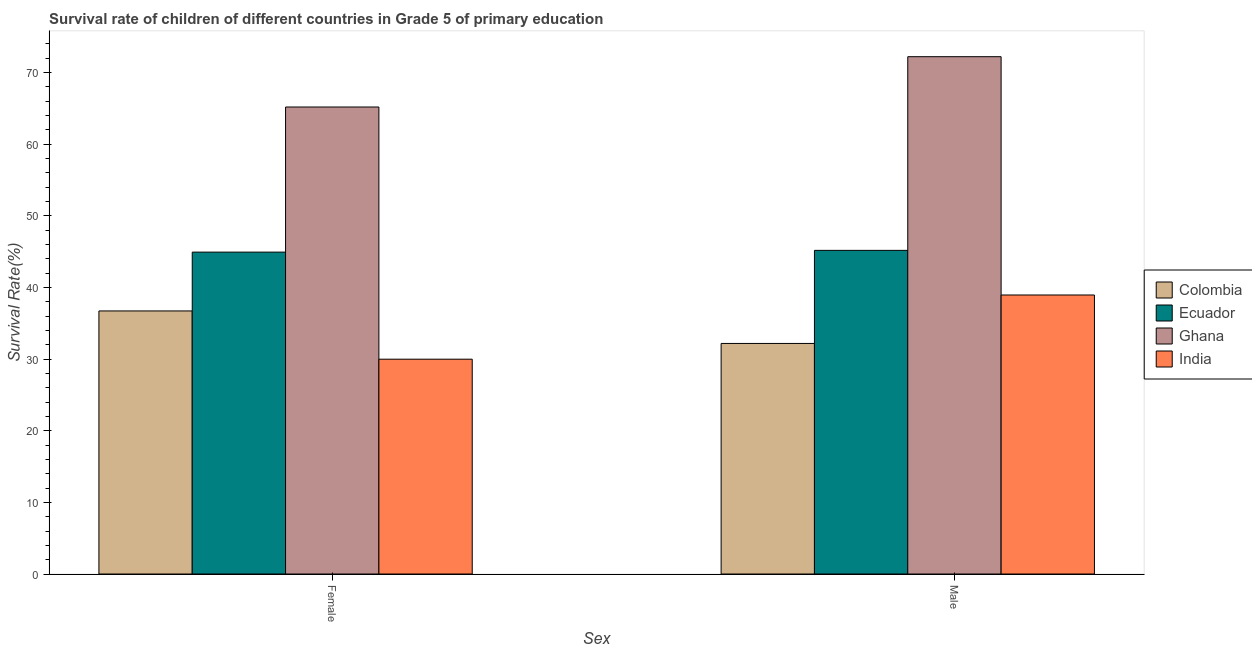How many different coloured bars are there?
Keep it short and to the point. 4. Are the number of bars per tick equal to the number of legend labels?
Your response must be concise. Yes. How many bars are there on the 2nd tick from the left?
Offer a very short reply. 4. How many bars are there on the 1st tick from the right?
Provide a short and direct response. 4. What is the label of the 1st group of bars from the left?
Ensure brevity in your answer.  Female. What is the survival rate of female students in primary education in Ghana?
Your answer should be very brief. 65.17. Across all countries, what is the maximum survival rate of male students in primary education?
Your answer should be very brief. 72.19. Across all countries, what is the minimum survival rate of female students in primary education?
Make the answer very short. 29.97. In which country was the survival rate of male students in primary education minimum?
Your answer should be very brief. Colombia. What is the total survival rate of female students in primary education in the graph?
Provide a short and direct response. 176.77. What is the difference between the survival rate of female students in primary education in Ecuador and that in Colombia?
Your answer should be compact. 8.21. What is the difference between the survival rate of male students in primary education in Ghana and the survival rate of female students in primary education in Colombia?
Make the answer very short. 35.48. What is the average survival rate of female students in primary education per country?
Your answer should be compact. 44.19. What is the difference between the survival rate of female students in primary education and survival rate of male students in primary education in Ecuador?
Make the answer very short. -0.24. In how many countries, is the survival rate of female students in primary education greater than 2 %?
Give a very brief answer. 4. What is the ratio of the survival rate of female students in primary education in Colombia to that in Ecuador?
Provide a succinct answer. 0.82. In how many countries, is the survival rate of male students in primary education greater than the average survival rate of male students in primary education taken over all countries?
Your answer should be very brief. 1. How many bars are there?
Provide a succinct answer. 8. Are all the bars in the graph horizontal?
Offer a terse response. No. How many countries are there in the graph?
Your answer should be compact. 4. Are the values on the major ticks of Y-axis written in scientific E-notation?
Offer a very short reply. No. Does the graph contain any zero values?
Provide a succinct answer. No. Where does the legend appear in the graph?
Give a very brief answer. Center right. How are the legend labels stacked?
Your answer should be very brief. Vertical. What is the title of the graph?
Keep it short and to the point. Survival rate of children of different countries in Grade 5 of primary education. Does "Latvia" appear as one of the legend labels in the graph?
Make the answer very short. No. What is the label or title of the X-axis?
Keep it short and to the point. Sex. What is the label or title of the Y-axis?
Your answer should be very brief. Survival Rate(%). What is the Survival Rate(%) in Colombia in Female?
Provide a succinct answer. 36.71. What is the Survival Rate(%) in Ecuador in Female?
Give a very brief answer. 44.92. What is the Survival Rate(%) in Ghana in Female?
Ensure brevity in your answer.  65.17. What is the Survival Rate(%) of India in Female?
Ensure brevity in your answer.  29.97. What is the Survival Rate(%) of Colombia in Male?
Your answer should be compact. 32.17. What is the Survival Rate(%) of Ecuador in Male?
Give a very brief answer. 45.16. What is the Survival Rate(%) in Ghana in Male?
Give a very brief answer. 72.19. What is the Survival Rate(%) of India in Male?
Ensure brevity in your answer.  38.93. Across all Sex, what is the maximum Survival Rate(%) in Colombia?
Provide a short and direct response. 36.71. Across all Sex, what is the maximum Survival Rate(%) of Ecuador?
Your answer should be very brief. 45.16. Across all Sex, what is the maximum Survival Rate(%) of Ghana?
Give a very brief answer. 72.19. Across all Sex, what is the maximum Survival Rate(%) in India?
Your answer should be very brief. 38.93. Across all Sex, what is the minimum Survival Rate(%) in Colombia?
Keep it short and to the point. 32.17. Across all Sex, what is the minimum Survival Rate(%) of Ecuador?
Provide a succinct answer. 44.92. Across all Sex, what is the minimum Survival Rate(%) of Ghana?
Your answer should be very brief. 65.17. Across all Sex, what is the minimum Survival Rate(%) in India?
Your answer should be compact. 29.97. What is the total Survival Rate(%) of Colombia in the graph?
Your answer should be very brief. 68.88. What is the total Survival Rate(%) in Ecuador in the graph?
Provide a succinct answer. 90.08. What is the total Survival Rate(%) of Ghana in the graph?
Keep it short and to the point. 137.35. What is the total Survival Rate(%) of India in the graph?
Keep it short and to the point. 68.91. What is the difference between the Survival Rate(%) of Colombia in Female and that in Male?
Offer a terse response. 4.54. What is the difference between the Survival Rate(%) of Ecuador in Female and that in Male?
Your answer should be compact. -0.24. What is the difference between the Survival Rate(%) of Ghana in Female and that in Male?
Your answer should be compact. -7.02. What is the difference between the Survival Rate(%) of India in Female and that in Male?
Offer a very short reply. -8.96. What is the difference between the Survival Rate(%) of Colombia in Female and the Survival Rate(%) of Ecuador in Male?
Your response must be concise. -8.45. What is the difference between the Survival Rate(%) of Colombia in Female and the Survival Rate(%) of Ghana in Male?
Ensure brevity in your answer.  -35.48. What is the difference between the Survival Rate(%) in Colombia in Female and the Survival Rate(%) in India in Male?
Make the answer very short. -2.23. What is the difference between the Survival Rate(%) of Ecuador in Female and the Survival Rate(%) of Ghana in Male?
Keep it short and to the point. -27.27. What is the difference between the Survival Rate(%) in Ecuador in Female and the Survival Rate(%) in India in Male?
Provide a succinct answer. 5.98. What is the difference between the Survival Rate(%) of Ghana in Female and the Survival Rate(%) of India in Male?
Provide a succinct answer. 26.23. What is the average Survival Rate(%) of Colombia per Sex?
Provide a short and direct response. 34.44. What is the average Survival Rate(%) of Ecuador per Sex?
Your response must be concise. 45.04. What is the average Survival Rate(%) in Ghana per Sex?
Keep it short and to the point. 68.68. What is the average Survival Rate(%) in India per Sex?
Your answer should be very brief. 34.45. What is the difference between the Survival Rate(%) in Colombia and Survival Rate(%) in Ecuador in Female?
Make the answer very short. -8.21. What is the difference between the Survival Rate(%) in Colombia and Survival Rate(%) in Ghana in Female?
Your answer should be very brief. -28.46. What is the difference between the Survival Rate(%) in Colombia and Survival Rate(%) in India in Female?
Your response must be concise. 6.73. What is the difference between the Survival Rate(%) in Ecuador and Survival Rate(%) in Ghana in Female?
Offer a very short reply. -20.25. What is the difference between the Survival Rate(%) in Ecuador and Survival Rate(%) in India in Female?
Your answer should be compact. 14.94. What is the difference between the Survival Rate(%) of Ghana and Survival Rate(%) of India in Female?
Make the answer very short. 35.19. What is the difference between the Survival Rate(%) in Colombia and Survival Rate(%) in Ecuador in Male?
Ensure brevity in your answer.  -12.99. What is the difference between the Survival Rate(%) of Colombia and Survival Rate(%) of Ghana in Male?
Keep it short and to the point. -40.02. What is the difference between the Survival Rate(%) of Colombia and Survival Rate(%) of India in Male?
Offer a very short reply. -6.76. What is the difference between the Survival Rate(%) in Ecuador and Survival Rate(%) in Ghana in Male?
Provide a short and direct response. -27.03. What is the difference between the Survival Rate(%) in Ecuador and Survival Rate(%) in India in Male?
Provide a succinct answer. 6.23. What is the difference between the Survival Rate(%) in Ghana and Survival Rate(%) in India in Male?
Ensure brevity in your answer.  33.25. What is the ratio of the Survival Rate(%) in Colombia in Female to that in Male?
Provide a short and direct response. 1.14. What is the ratio of the Survival Rate(%) in Ghana in Female to that in Male?
Ensure brevity in your answer.  0.9. What is the ratio of the Survival Rate(%) in India in Female to that in Male?
Your answer should be compact. 0.77. What is the difference between the highest and the second highest Survival Rate(%) in Colombia?
Your response must be concise. 4.54. What is the difference between the highest and the second highest Survival Rate(%) in Ecuador?
Give a very brief answer. 0.24. What is the difference between the highest and the second highest Survival Rate(%) in Ghana?
Ensure brevity in your answer.  7.02. What is the difference between the highest and the second highest Survival Rate(%) in India?
Your answer should be very brief. 8.96. What is the difference between the highest and the lowest Survival Rate(%) in Colombia?
Provide a succinct answer. 4.54. What is the difference between the highest and the lowest Survival Rate(%) of Ecuador?
Provide a short and direct response. 0.24. What is the difference between the highest and the lowest Survival Rate(%) in Ghana?
Offer a very short reply. 7.02. What is the difference between the highest and the lowest Survival Rate(%) in India?
Provide a succinct answer. 8.96. 